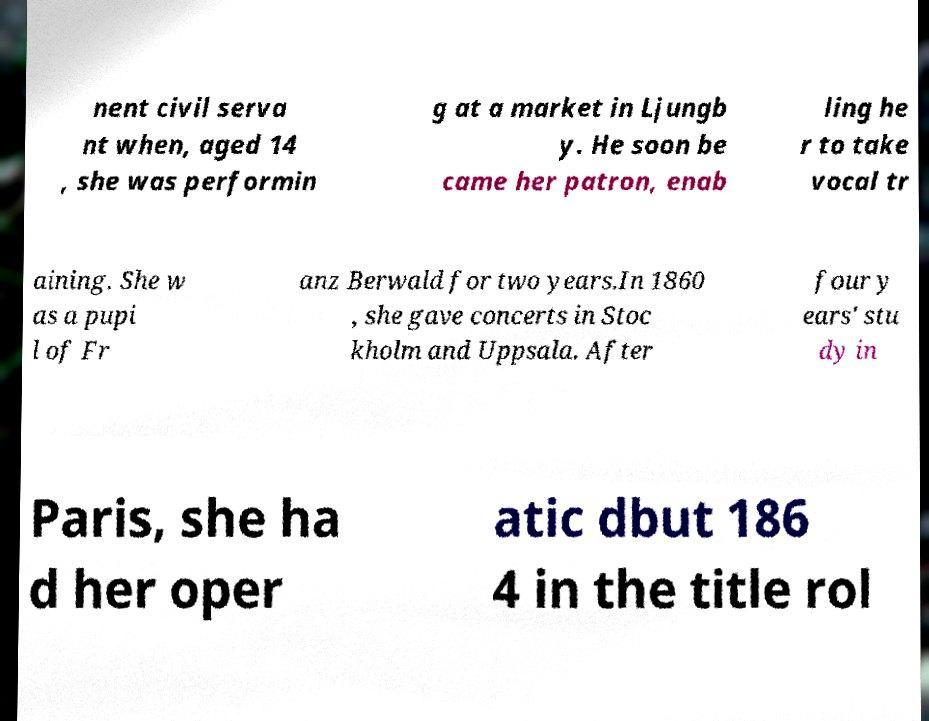Could you extract and type out the text from this image? nent civil serva nt when, aged 14 , she was performin g at a market in Ljungb y. He soon be came her patron, enab ling he r to take vocal tr aining. She w as a pupi l of Fr anz Berwald for two years.In 1860 , she gave concerts in Stoc kholm and Uppsala. After four y ears' stu dy in Paris, she ha d her oper atic dbut 186 4 in the title rol 